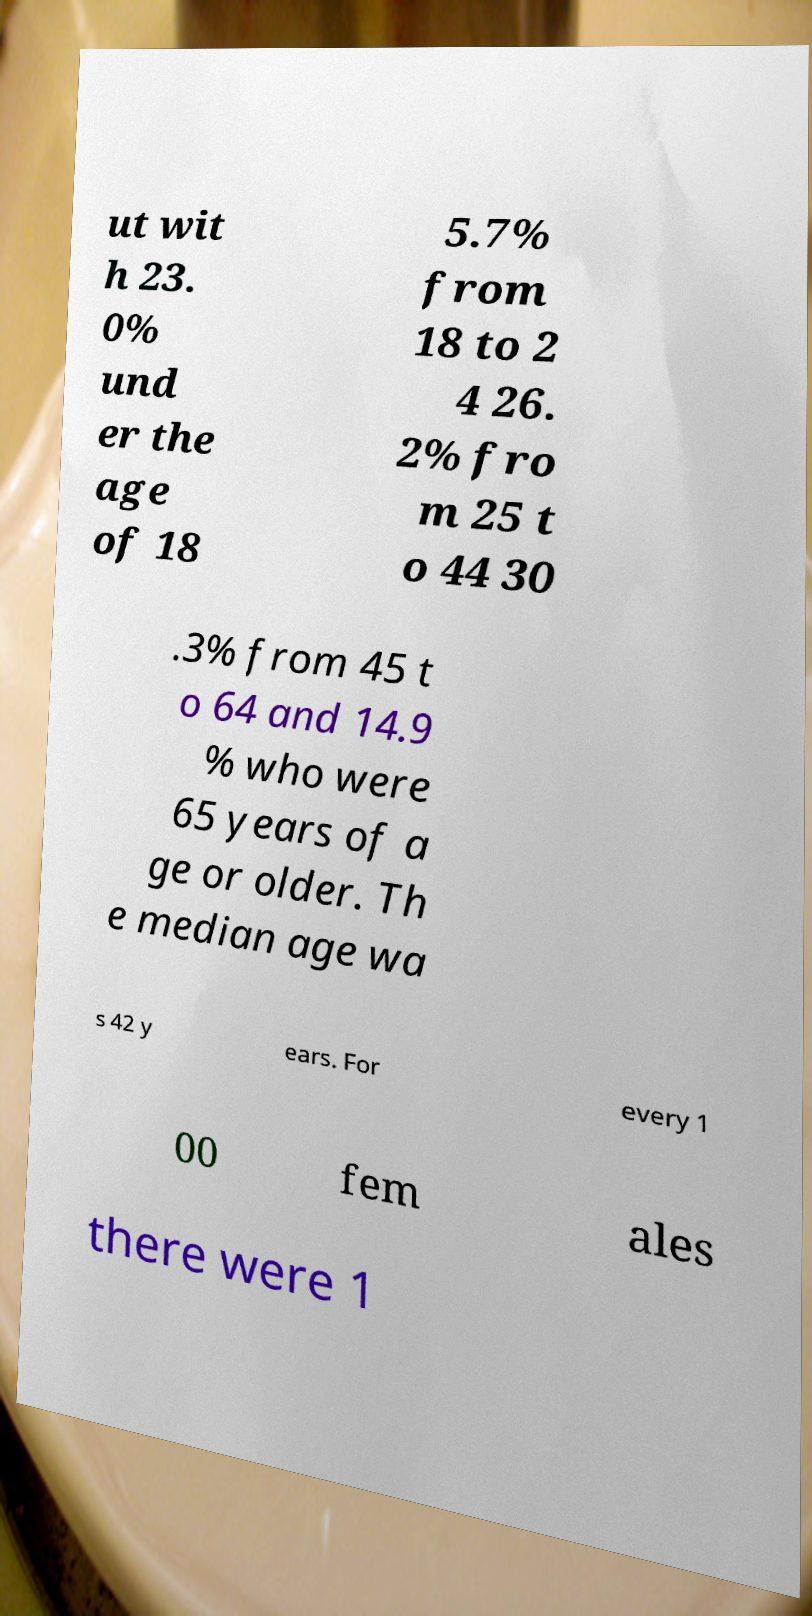What messages or text are displayed in this image? I need them in a readable, typed format. ut wit h 23. 0% und er the age of 18 5.7% from 18 to 2 4 26. 2% fro m 25 t o 44 30 .3% from 45 t o 64 and 14.9 % who were 65 years of a ge or older. Th e median age wa s 42 y ears. For every 1 00 fem ales there were 1 